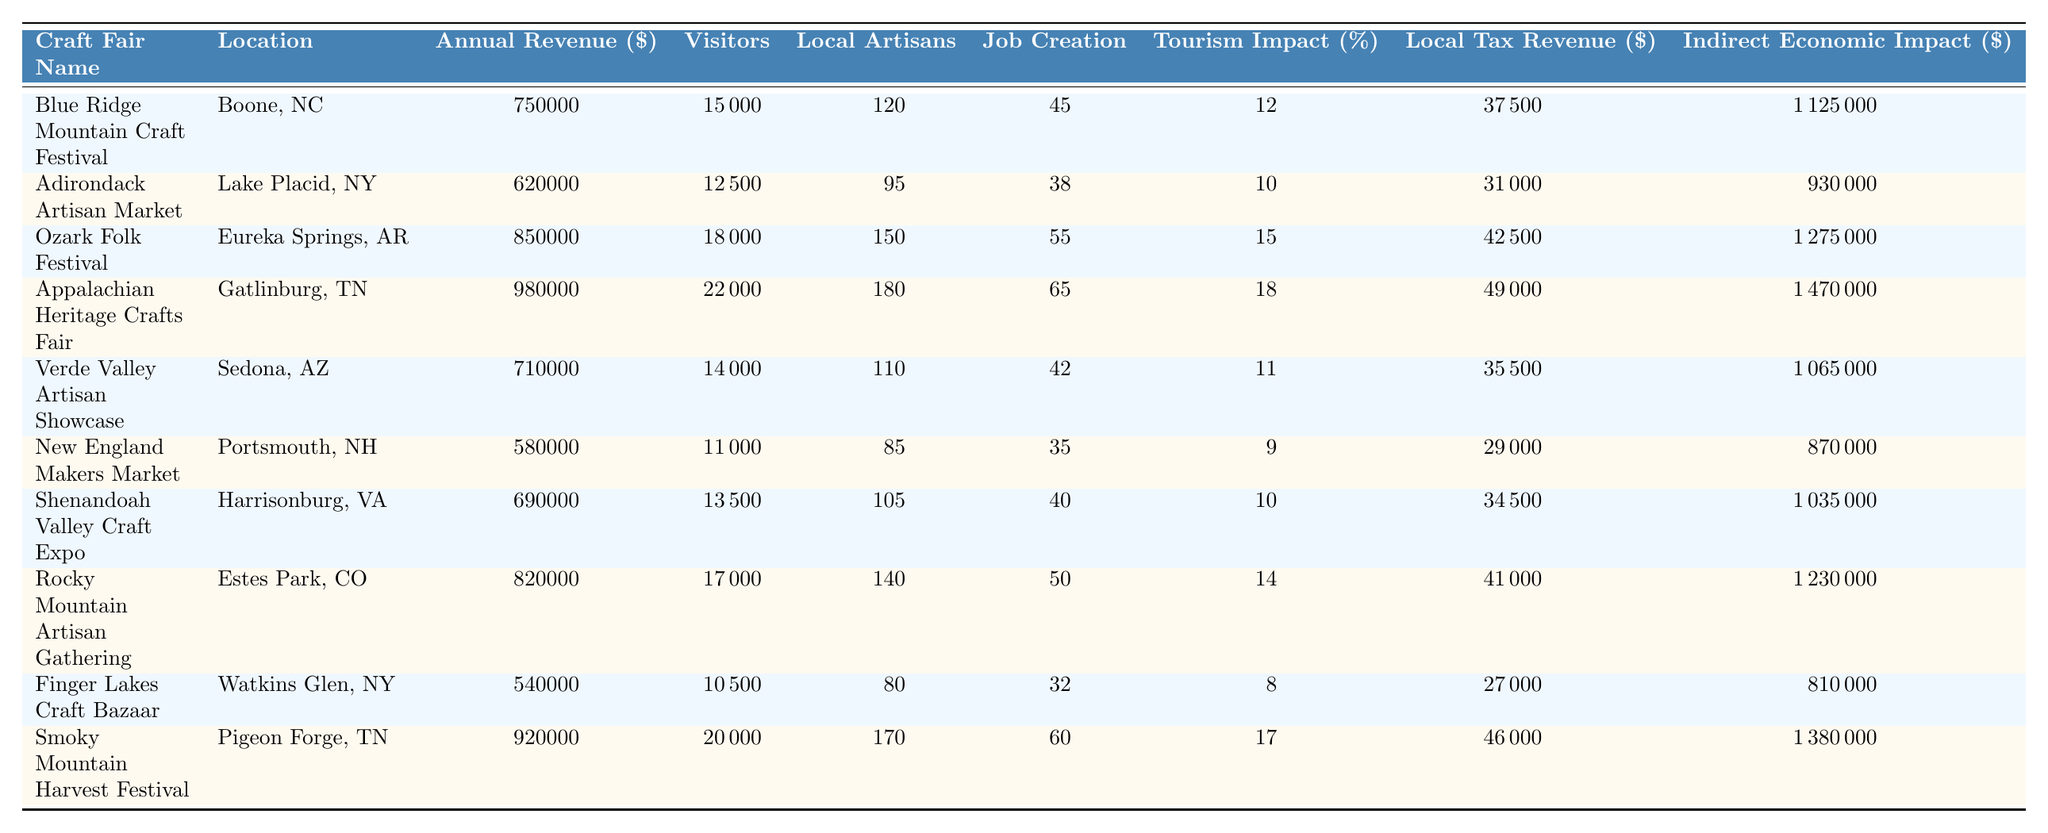What is the highest annual revenue among the craft fairs listed? The annual revenues are as follows: 750000, 620000, 850000, 980000, 710000, 580000, 690000, 820000, 540000, and 920000. The highest value is 980000 from the Appalachian Heritage Crafts Fair.
Answer: 980000 How many visitors did the Smoky Mountain Harvest Festival attract? The visitor count for the Smoky Mountain Harvest Festival is listed as 20000.
Answer: 20000 Which craft fair had the most local artisans participating? The number of local artisans participating is as follows: 120, 95, 150, 180, 110, 85, 105, 140, 80, and 170. The highest value is 180 from the Appalachian Heritage Crafts Fair.
Answer: 180 What is the total indirect economic impact of the craft fairs combined? The indirect economic impacts are: 1125000, 930000, 1275000, 1470000, 1065000, 870000, 1035000, 1230000, 810000, and 1380000. Summing these gives 1125000 + 930000 + 1275000 + 1470000 + 1065000 + 870000 + 1035000 + 1230000 + 810000 + 1380000 = 12750000.
Answer: 12750000 Is the tourism impact of the Adirondack Artisan Market greater than 10%? The tourism impact is listed as 10% for the Adirondack Artisan Market, which is equal to but not greater than 10%.
Answer: No What is the average annual revenue of all the craft fairs? Sum the annual revenues: 750000 + 620000 + 850000 + 980000 + 710000 + 580000 + 690000 + 820000 + 540000 + 920000 =  7250000. Then divide by the number of fairs (10), giving: 7250000 / 10 = 725000.
Answer: 725000 How many more jobs were created by the Appalachian Heritage Crafts Fair compared to the Ozark Folk Festival? Job creation numbers are 65 for the Appalachian Heritage Crafts Fair and 55 for the Ozark Folk Festival. Finding the difference: 65 - 55 = 10.
Answer: 10 Which location had the least local tax revenue generated? The local tax revenues are: 37500, 31000, 42500, 49000, 35500, 29000, 34500, 41000, 27000, and 46000. The minimum value is 27000 from the Finger Lakes Craft Bazaar.
Answer: 27000 What is the percentage of the job creation from the total visitors for the Rocky Mountain Artisan Gathering? The job creation is 50 and the number of visitors is 17000. The percentage of job creation from visitors is calculated as (50 / 17000) * 100 ≈ 0.294%.
Answer: 0.294% Which fair has the highest tourism impact percentage, and what is that percentage? The tourism impacts are: 12%, 10%, 15%, 18%, 11%, 9%, 10%, 14%, 8%, and 17%. The highest value is 18% from the Appalachian Heritage Crafts Fair.
Answer: 18% 